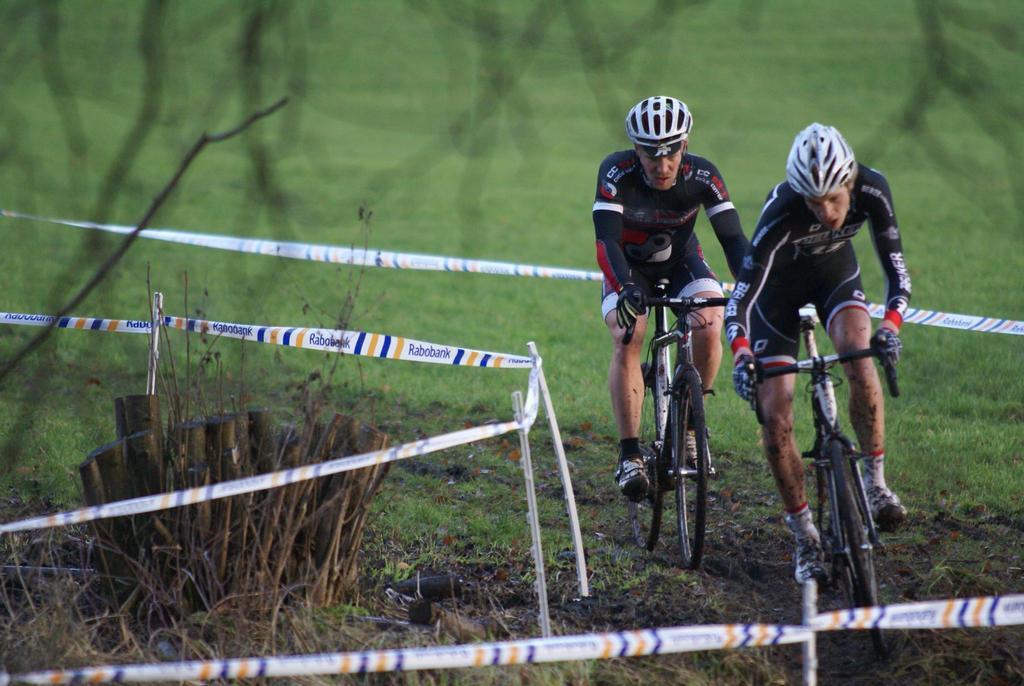Can you describe this image briefly? In the picture I can see two men riding a bicycle. They are wearing a sport dress and there is a helmet on their heads. I can see the fence and green grass in the image. 